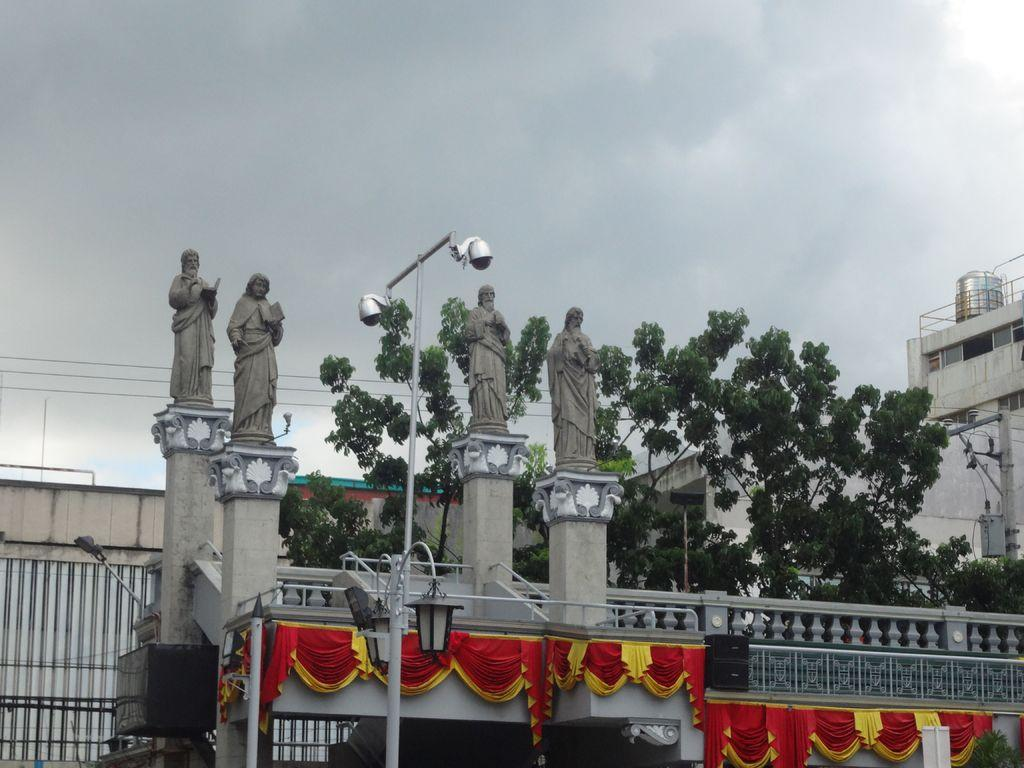How many sculptures of people are in the image? There are four sculptures of people in the image. What other objects can be seen in the image besides the sculptures? There is a light pole, a sound box, a fence, electric wires, trees, a building, and a decorative cloth in the image. What is the condition of the sky in the image? The sky in the image is cloudy. Can you tell me the route the cook takes to reach the stream in the image? There is no cook or stream present in the image, so it is not possible to determine a route. 